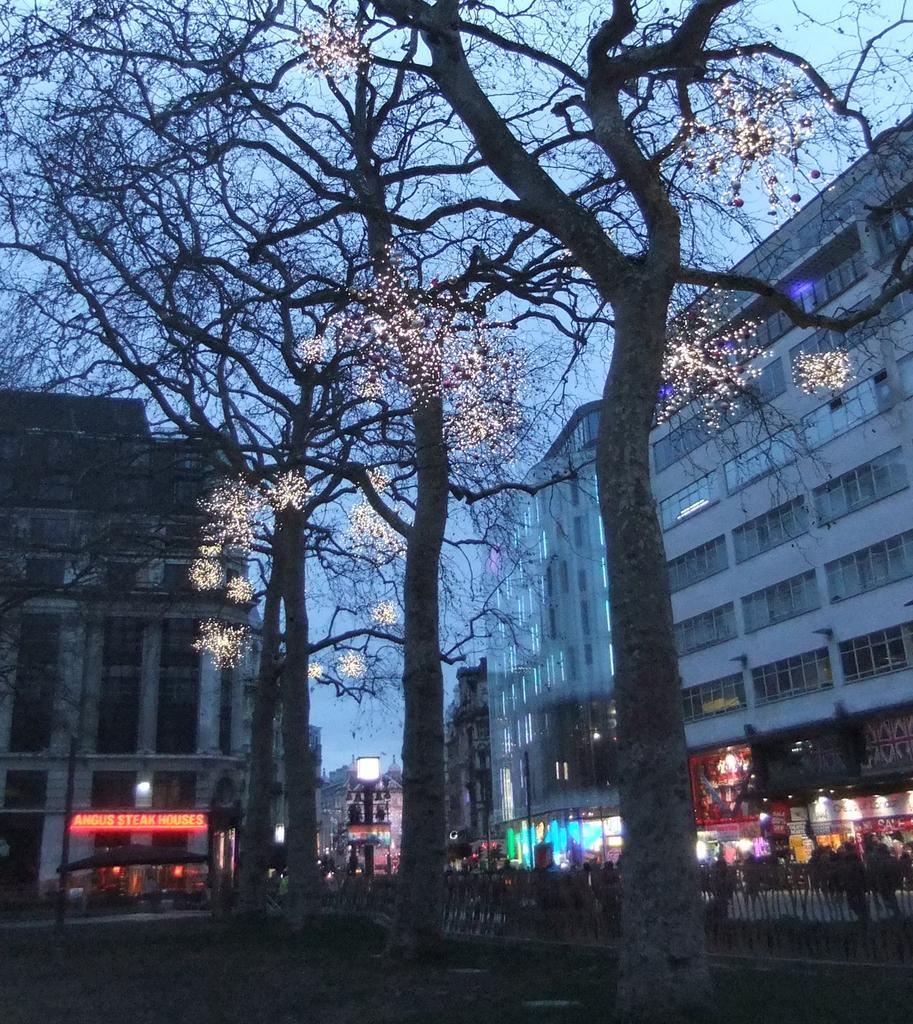Please provide a concise description of this image. There are trees with light in the foreground area of the image, there are buildings, stalls, light and the sky in the background. 